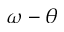<formula> <loc_0><loc_0><loc_500><loc_500>\omega - \theta</formula> 